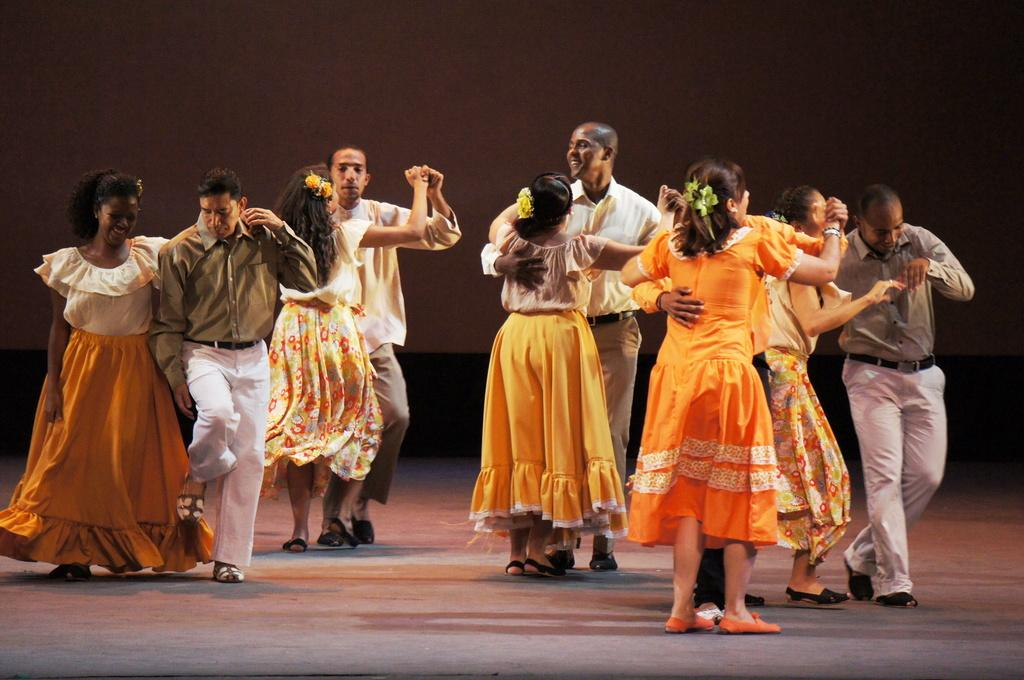What are the people in the image doing? The people in the image are couples dancing. Where are the couples dancing? The couples are dancing on the floor. What can be seen in the background of the image? There is a wall visible in the background of the image. What type of government is depicted in the image? There is no depiction of a government in the image; it features couples dancing on the floor. Can you see the sea in the background of the image? No, the sea is not visible in the image; there is only a wall visible in the background. 